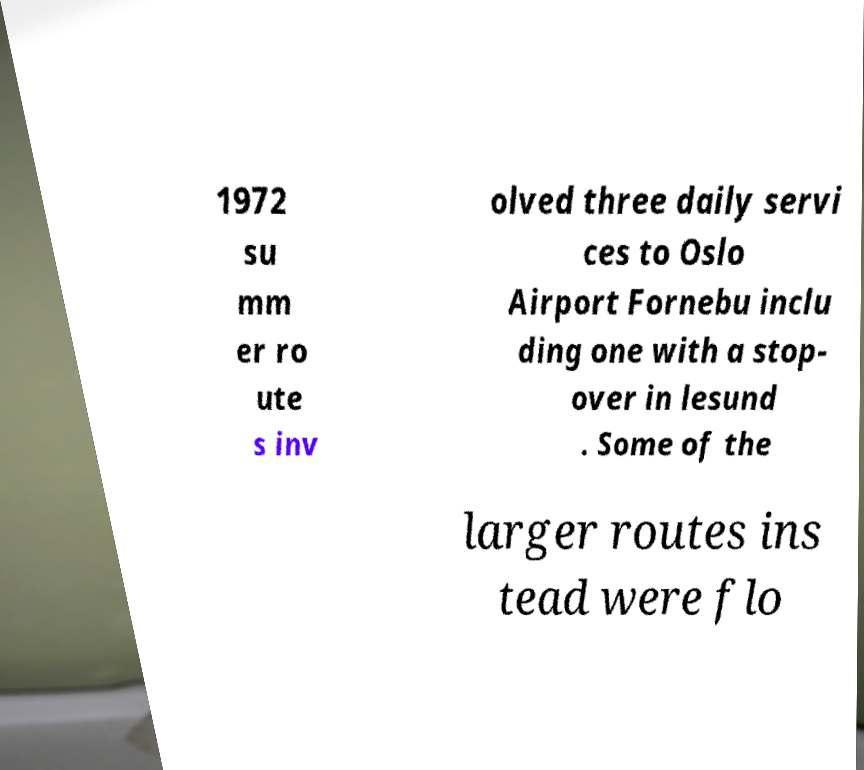Please read and relay the text visible in this image. What does it say? 1972 su mm er ro ute s inv olved three daily servi ces to Oslo Airport Fornebu inclu ding one with a stop- over in lesund . Some of the larger routes ins tead were flo 